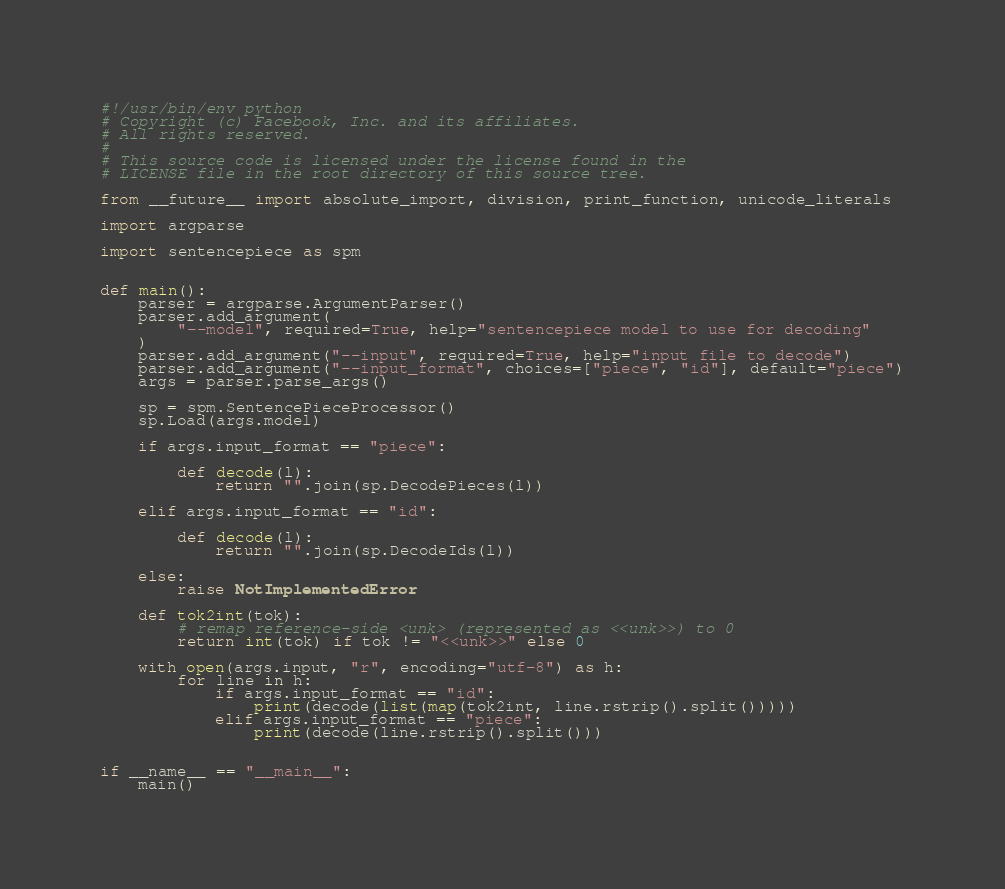<code> <loc_0><loc_0><loc_500><loc_500><_Python_>#!/usr/bin/env python
# Copyright (c) Facebook, Inc. and its affiliates.
# All rights reserved.
#
# This source code is licensed under the license found in the
# LICENSE file in the root directory of this source tree.

from __future__ import absolute_import, division, print_function, unicode_literals

import argparse

import sentencepiece as spm


def main():
    parser = argparse.ArgumentParser()
    parser.add_argument(
        "--model", required=True, help="sentencepiece model to use for decoding"
    )
    parser.add_argument("--input", required=True, help="input file to decode")
    parser.add_argument("--input_format", choices=["piece", "id"], default="piece")
    args = parser.parse_args()

    sp = spm.SentencePieceProcessor()
    sp.Load(args.model)

    if args.input_format == "piece":

        def decode(l):
            return "".join(sp.DecodePieces(l))

    elif args.input_format == "id":

        def decode(l):
            return "".join(sp.DecodeIds(l))

    else:
        raise NotImplementedError

    def tok2int(tok):
        # remap reference-side <unk> (represented as <<unk>>) to 0
        return int(tok) if tok != "<<unk>>" else 0

    with open(args.input, "r", encoding="utf-8") as h:
        for line in h:
            if args.input_format == "id":
                print(decode(list(map(tok2int, line.rstrip().split()))))
            elif args.input_format == "piece":
                print(decode(line.rstrip().split()))


if __name__ == "__main__":
    main()
</code> 